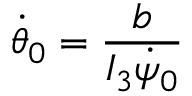Convert formula to latex. <formula><loc_0><loc_0><loc_500><loc_500>\dot { \theta } _ { 0 } = \frac { b } { I _ { 3 } \dot { \psi } _ { 0 } }</formula> 